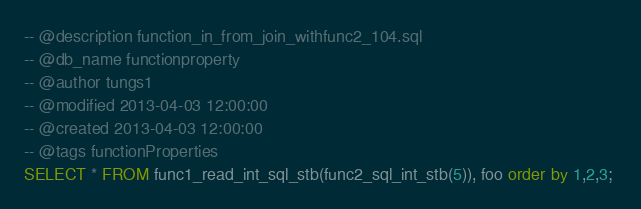<code> <loc_0><loc_0><loc_500><loc_500><_SQL_>-- @description function_in_from_join_withfunc2_104.sql
-- @db_name functionproperty
-- @author tungs1
-- @modified 2013-04-03 12:00:00
-- @created 2013-04-03 12:00:00
-- @tags functionProperties 
SELECT * FROM func1_read_int_sql_stb(func2_sql_int_stb(5)), foo order by 1,2,3; 
</code> 